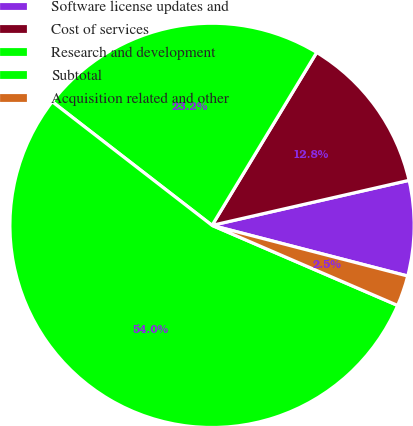Convert chart. <chart><loc_0><loc_0><loc_500><loc_500><pie_chart><fcel>Software license updates and<fcel>Cost of services<fcel>Research and development<fcel>Subtotal<fcel>Acquisition related and other<nl><fcel>7.61%<fcel>12.76%<fcel>23.18%<fcel>54.0%<fcel>2.45%<nl></chart> 